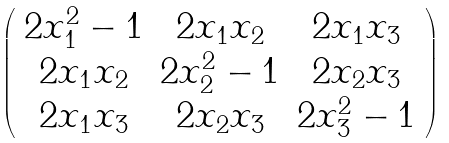<formula> <loc_0><loc_0><loc_500><loc_500>\left ( \begin{array} { c c c } 2 x _ { 1 } ^ { 2 } - 1 & 2 x _ { 1 } x _ { 2 } & 2 x _ { 1 } x _ { 3 } \\ 2 x _ { 1 } x _ { 2 } & 2 x _ { 2 } ^ { 2 } - 1 & 2 x _ { 2 } x _ { 3 } \\ 2 x _ { 1 } x _ { 3 } & 2 x _ { 2 } x _ { 3 } & 2 x _ { 3 } ^ { 2 } - 1 \end{array} \right )</formula> 